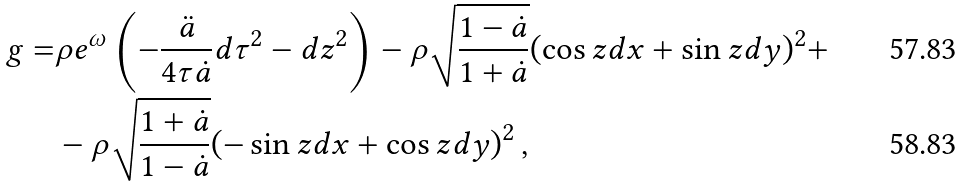<formula> <loc_0><loc_0><loc_500><loc_500>g = & \rho e ^ { \omega } \left ( - \frac { \ddot { a } } { 4 \tau \dot { a } } d \tau ^ { 2 } - d z ^ { 2 } \right ) - \rho \sqrt { \frac { 1 - \dot { a } } { 1 + \dot { a } } } ( \cos z d x + \sin z d y ) ^ { 2 } + \\ & - \rho \sqrt { \frac { 1 + \dot { a } } { 1 - \dot { a } } } ( - \sin z d x + \cos z d y ) ^ { 2 } \, ,</formula> 